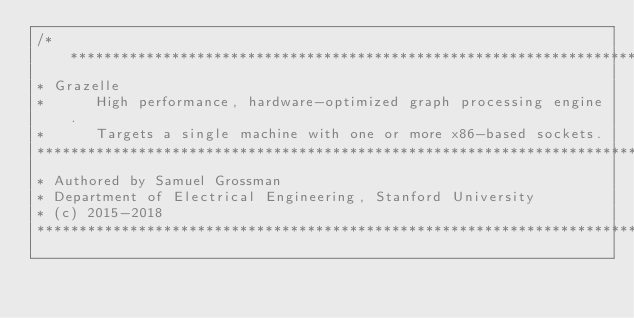Convert code to text. <code><loc_0><loc_0><loc_500><loc_500><_C_>/*****************************************************************************
* Grazelle
*      High performance, hardware-optimized graph processing engine.
*      Targets a single machine with one or more x86-based sockets.
*****************************************************************************
* Authored by Samuel Grossman
* Department of Electrical Engineering, Stanford University
* (c) 2015-2018
*****************************************************************************</code> 